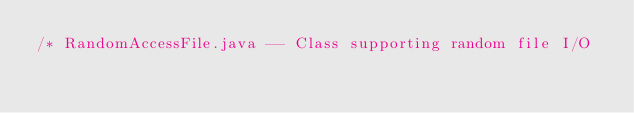<code> <loc_0><loc_0><loc_500><loc_500><_Java_>/* RandomAccessFile.java -- Class supporting random file I/O</code> 